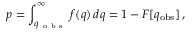<formula> <loc_0><loc_0><loc_500><loc_500>p = \int _ { q _ { o b s } } ^ { \infty } f ( q ) \, d q = 1 - F [ q _ { o b s } ] \, ,</formula> 